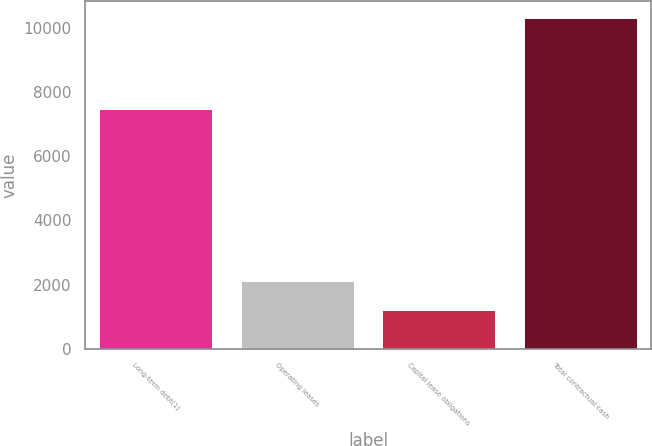<chart> <loc_0><loc_0><loc_500><loc_500><bar_chart><fcel>Long-term debt(1)<fcel>Operating leases<fcel>Capital lease obligations<fcel>Total contractual cash<nl><fcel>7473<fcel>2104.4<fcel>1192<fcel>10316<nl></chart> 